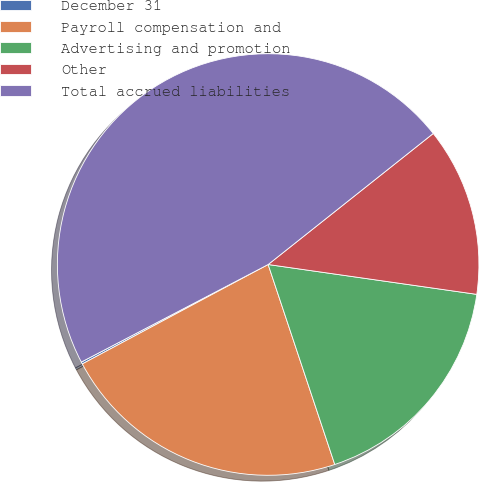Convert chart. <chart><loc_0><loc_0><loc_500><loc_500><pie_chart><fcel>December 31<fcel>Payroll compensation and<fcel>Advertising and promotion<fcel>Other<fcel>Total accrued liabilities<nl><fcel>0.16%<fcel>22.3%<fcel>17.62%<fcel>12.94%<fcel>46.98%<nl></chart> 